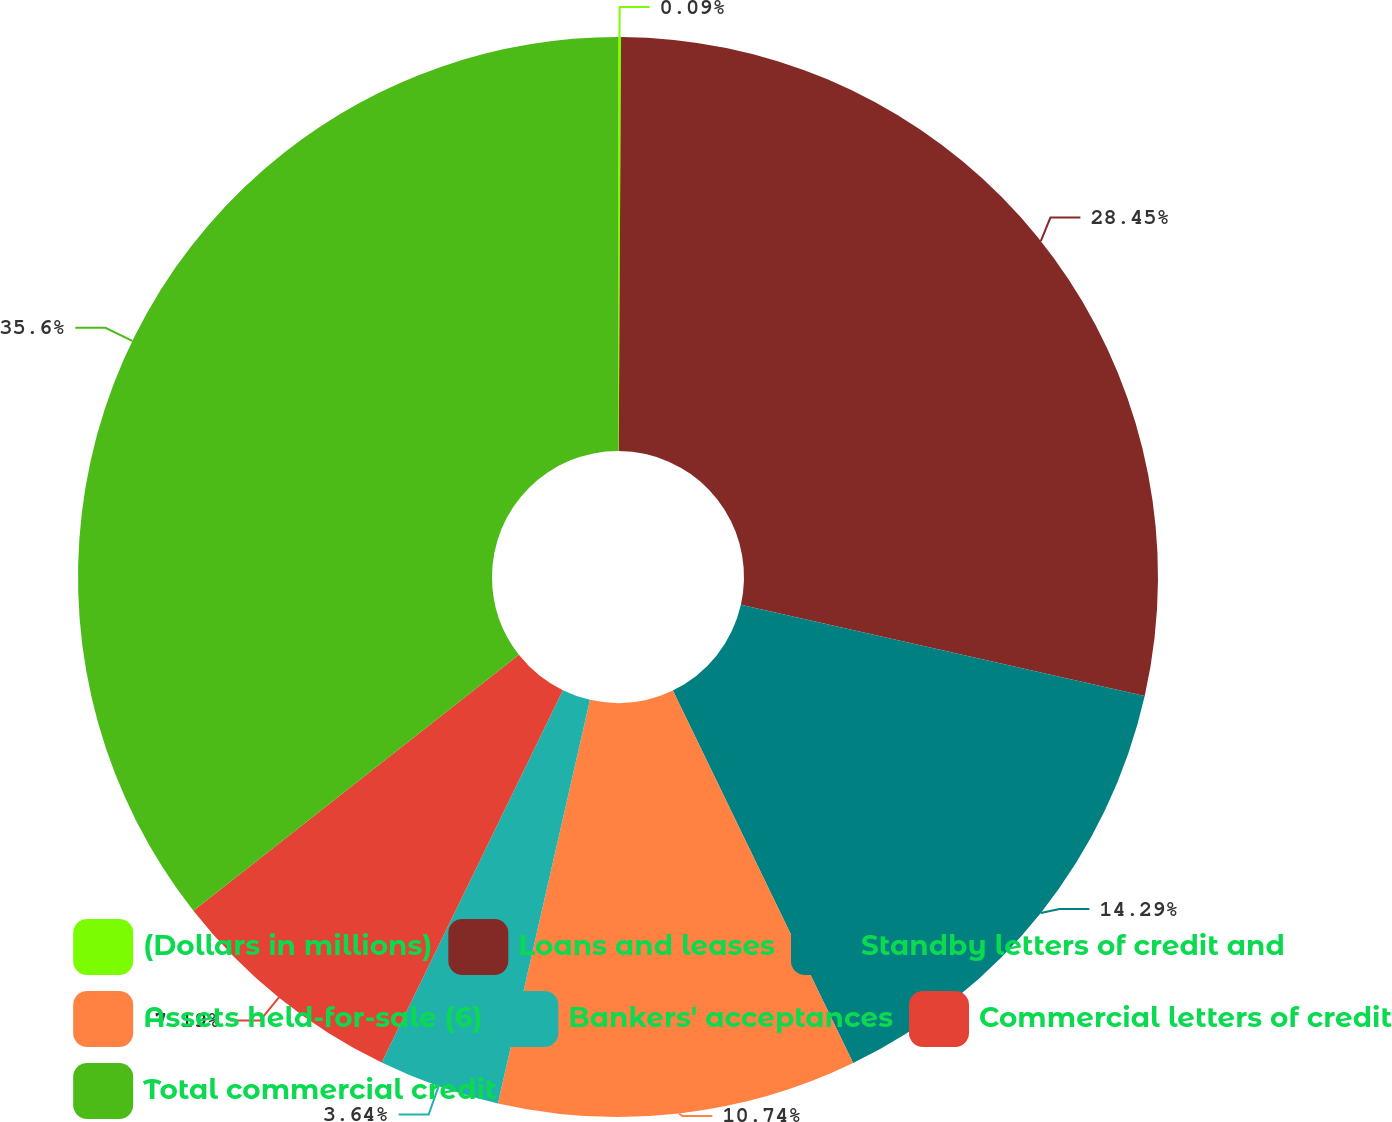Convert chart to OTSL. <chart><loc_0><loc_0><loc_500><loc_500><pie_chart><fcel>(Dollars in millions)<fcel>Loans and leases<fcel>Standby letters of credit and<fcel>Assets held-for-sale (6)<fcel>Bankers' acceptances<fcel>Commercial letters of credit<fcel>Total commercial credit<nl><fcel>0.09%<fcel>28.45%<fcel>14.29%<fcel>10.74%<fcel>3.64%<fcel>7.19%<fcel>35.6%<nl></chart> 